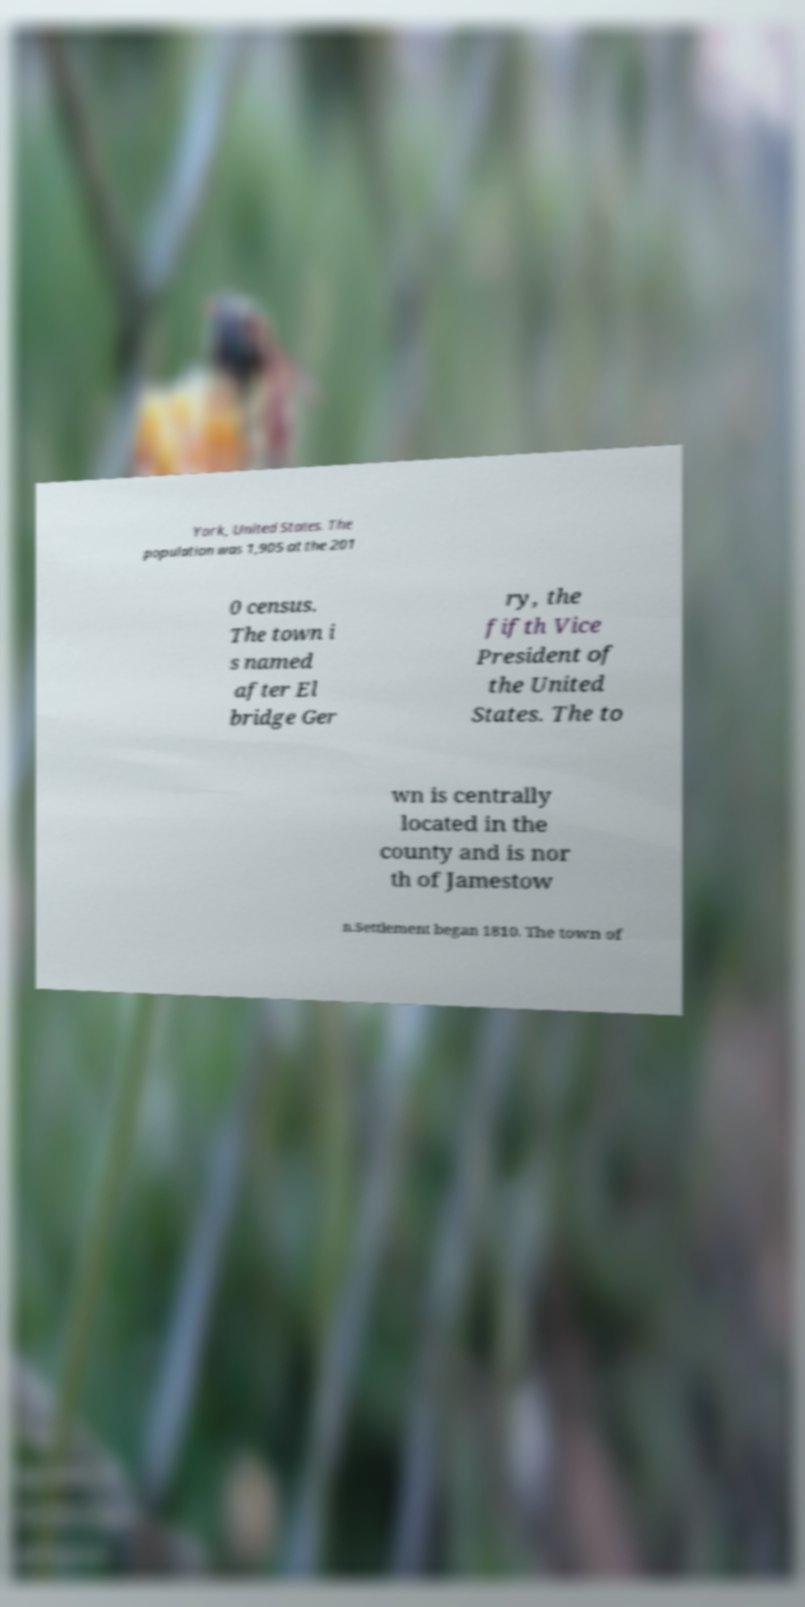There's text embedded in this image that I need extracted. Can you transcribe it verbatim? York, United States. The population was 1,905 at the 201 0 census. The town i s named after El bridge Ger ry, the fifth Vice President of the United States. The to wn is centrally located in the county and is nor th of Jamestow n.Settlement began 1810. The town of 